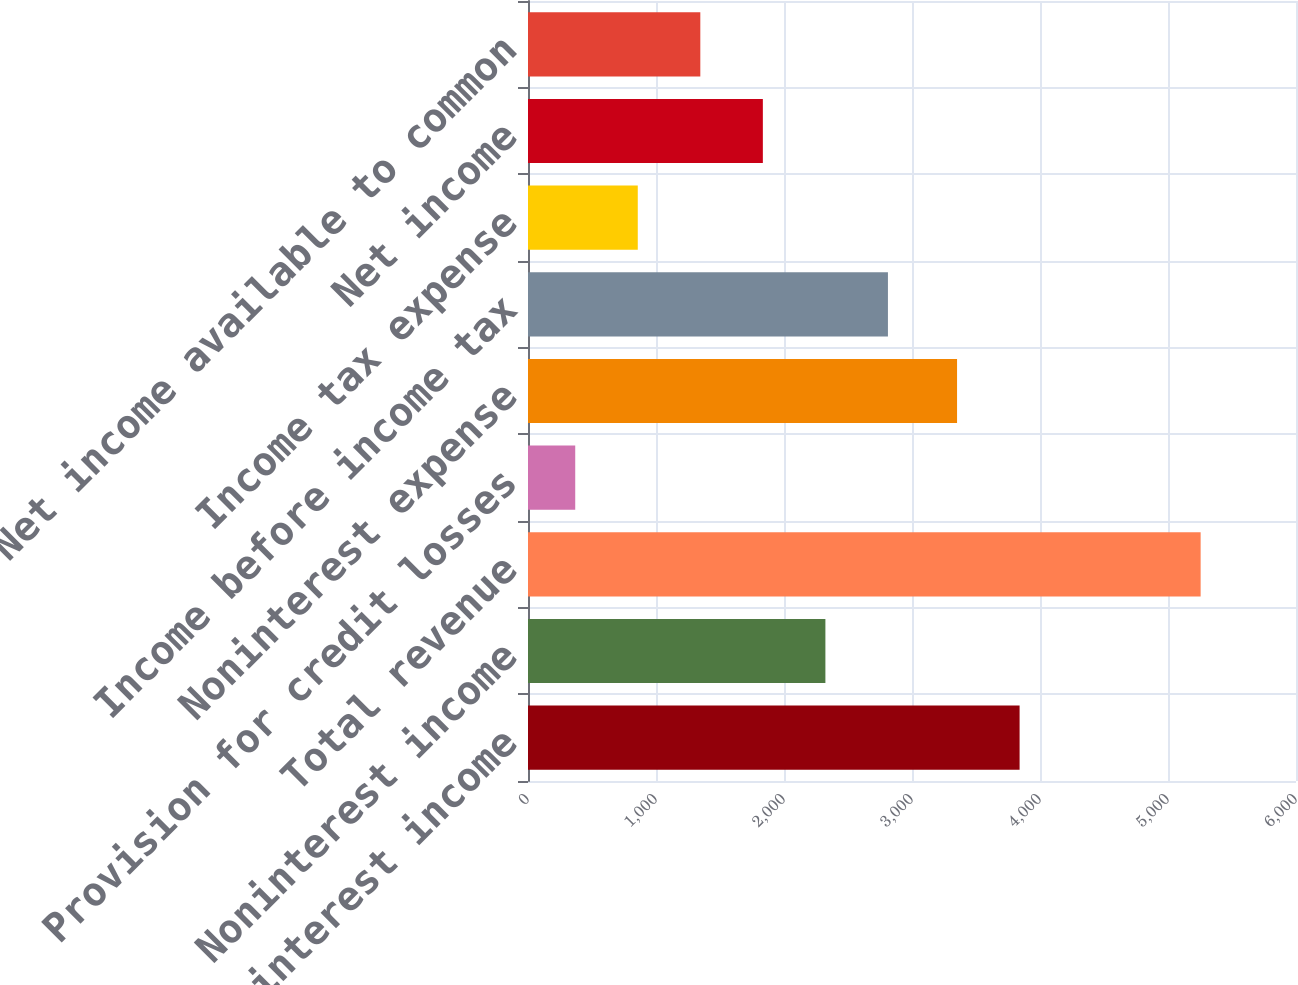Convert chart. <chart><loc_0><loc_0><loc_500><loc_500><bar_chart><fcel>Net interest income<fcel>Noninterest income<fcel>Total revenue<fcel>Provision for credit losses<fcel>Noninterest expense<fcel>Income before income tax<fcel>Income tax expense<fcel>Net income<fcel>Net income available to common<nl><fcel>3840.6<fcel>2323.4<fcel>5255<fcel>369<fcel>3352<fcel>2812<fcel>857.6<fcel>1834.8<fcel>1346.2<nl></chart> 